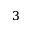<formula> <loc_0><loc_0><loc_500><loc_500>3</formula> 